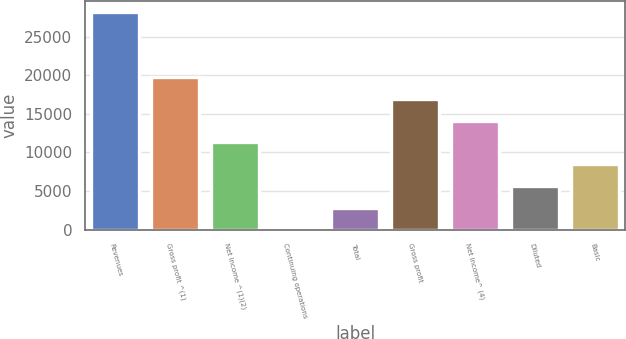Convert chart. <chart><loc_0><loc_0><loc_500><loc_500><bar_chart><fcel>Revenues<fcel>Gross profit ^(1)<fcel>Net income ^(1)(2)<fcel>Continuing operations<fcel>Total<fcel>Gross profit<fcel>Net income^ (4)<fcel>Diluted<fcel>Basic<nl><fcel>28247<fcel>19773.1<fcel>11299.2<fcel>0.6<fcel>2825.24<fcel>16948.4<fcel>14123.8<fcel>5649.88<fcel>8474.52<nl></chart> 